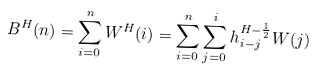<formula> <loc_0><loc_0><loc_500><loc_500>B ^ { H } ( n ) = \sum _ { i = 0 } ^ { n } W ^ { H } ( i ) = \sum _ { i = 0 } ^ { n } \sum _ { j = 0 } ^ { i } h _ { i - j } ^ { H - \frac { 1 } { 2 } } W ( j )</formula> 